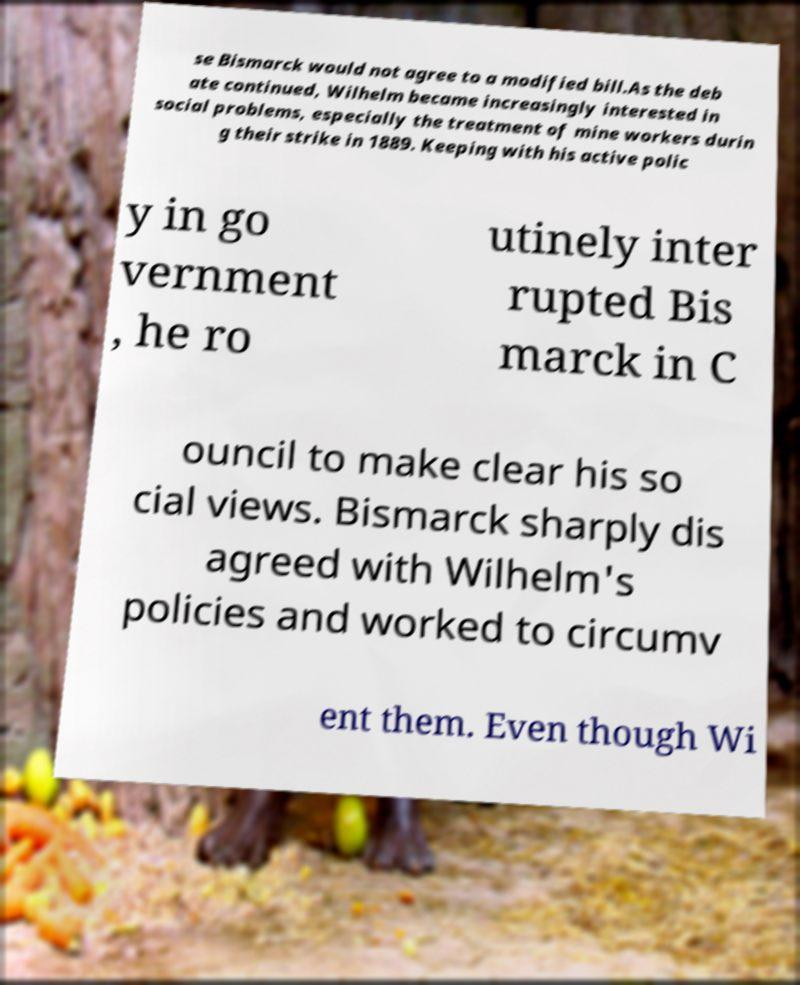There's text embedded in this image that I need extracted. Can you transcribe it verbatim? se Bismarck would not agree to a modified bill.As the deb ate continued, Wilhelm became increasingly interested in social problems, especially the treatment of mine workers durin g their strike in 1889. Keeping with his active polic y in go vernment , he ro utinely inter rupted Bis marck in C ouncil to make clear his so cial views. Bismarck sharply dis agreed with Wilhelm's policies and worked to circumv ent them. Even though Wi 